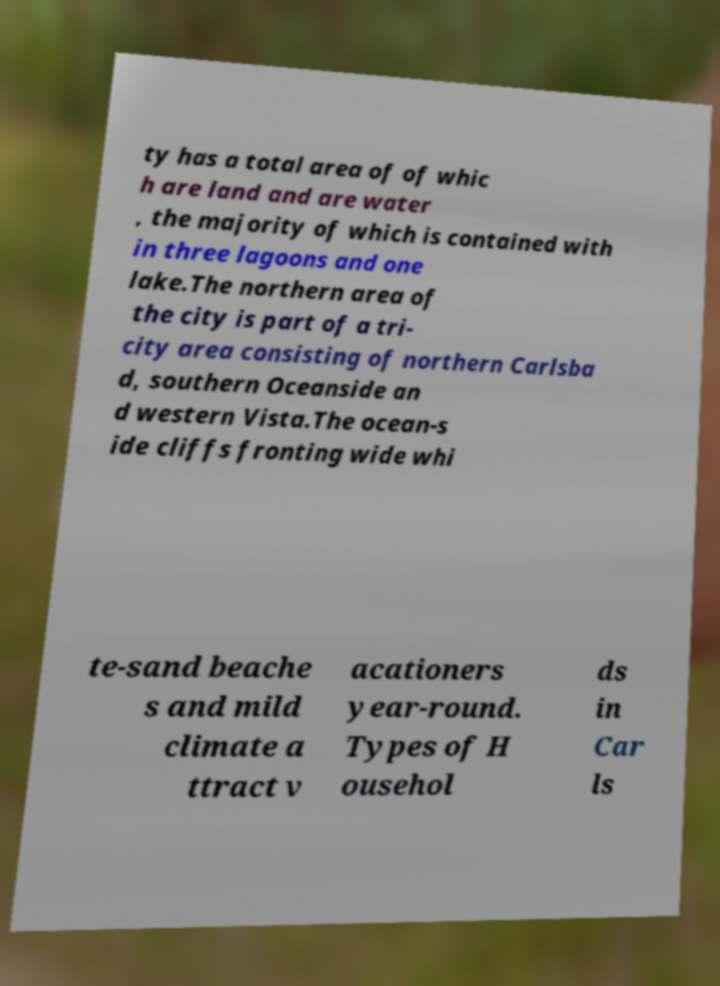For documentation purposes, I need the text within this image transcribed. Could you provide that? ty has a total area of of whic h are land and are water , the majority of which is contained with in three lagoons and one lake.The northern area of the city is part of a tri- city area consisting of northern Carlsba d, southern Oceanside an d western Vista.The ocean-s ide cliffs fronting wide whi te-sand beache s and mild climate a ttract v acationers year-round. Types of H ousehol ds in Car ls 